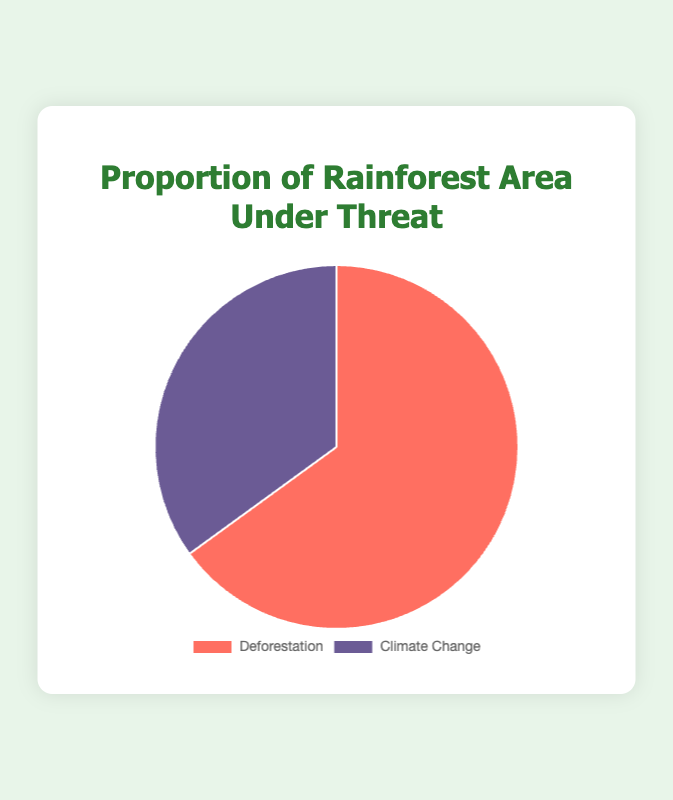Which category constitutes the larger proportion of the rainforest area under threat? By examining the pie chart, you can see that 'Deforestation' occupies a larger segment of the pie chart compared to 'Climate Change'.
Answer: Deforestation What is the difference in proportions between areas threatened by deforestation and climate change? From the chart, deforestation is at 65% and climate change is at 35%. The difference is 65 - 35 = 30.
Answer: 30 If the total rainforest area under threat is 1000 square kilometers, how many square kilometers are threatened by climate change? Given that 35% of the total area is under threat due to climate change, calculate the area as 35/100 * 1000 = 350 square kilometers.
Answer: 350 What is the combined proportion of rainforest area under threat from both deforestation and climate change? Refer to the pie chart where deforestation is 65% and climate change is 35%. Adding them yields 65 + 35 = 100.
Answer: 100 How many times greater is the proportion of rainforest area under threat from deforestation compared to climate change? The proportion for deforestation is 65% and for climate change is 35%. Dividing the former by the latter results in 65 / 35 = 1.857, approximately 1.86 times.
Answer: 1.86 Which category is represented by the purple segment of the pie chart? In the pie chart, the category represented by purple is 'Climate Change'.
Answer: Climate Change If the total endangered rainforest area increased by 10% while the proportions remained the same, what would be the new area threatened by deforestation, given the original area is 800 square kilometers? First, calculate the increased total area: 800 + 10% of 800 = 880 square kilometers. Then, calculate the area threatened by deforestation: 65% of 880 = 572 square kilometers.
Answer: 572 If the proportion for climate change decreases by 5% without changing the total proportion, what would be the new proportions for deforestation and climate change? If climate change decreases by 5%, it becomes 35 - 5 = 30%. The total must remain 100%, so deforestation increases to 65 + 5 = 70%.
Answer: Deforestation: 70%, Climate Change: 30% What proportion does the red segment represent? The pie chart shows the red segment represents 'Deforestation'. According to the data, deforestation is 65%.
Answer: 65% What is the average proportion of the two categories? The proportions are 65 for deforestation and 35 for climate change. Calculating the average: (65 + 35) / 2 = 50.
Answer: 50 